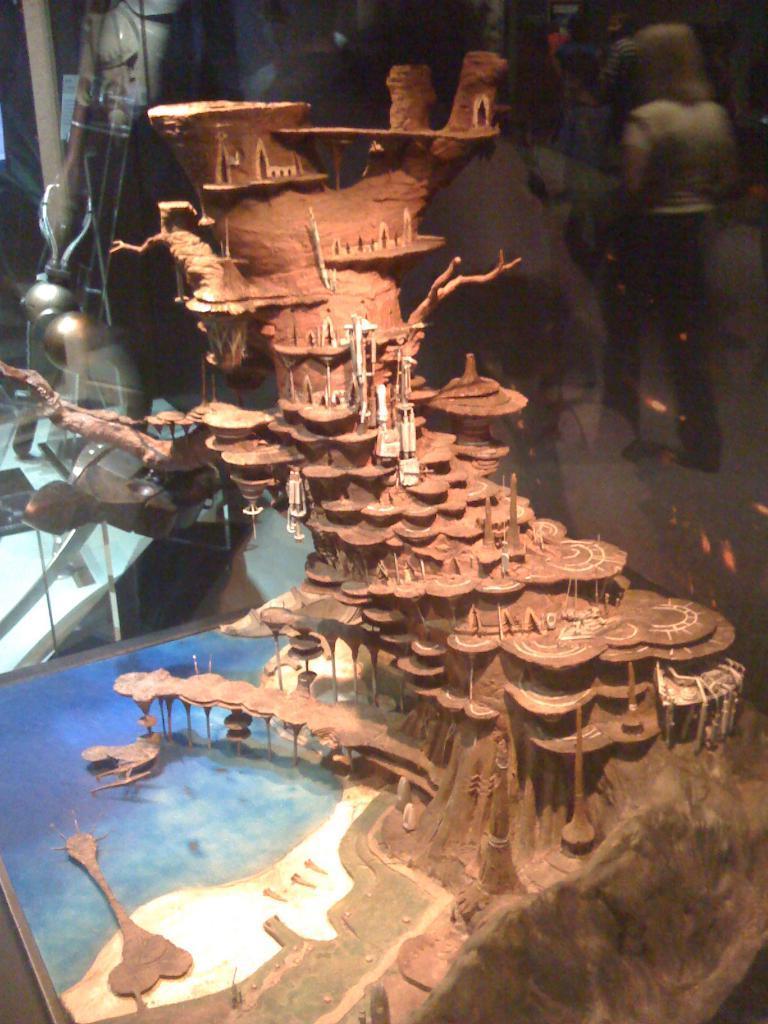Can you describe this image briefly? In this image I can see a tree trunk which is carved into the shape of a fort which is brown in color. I can see the water, a bridge and the ground in the miniature. In the background I can see the glass in which I can see the reflection of few persons standing. 